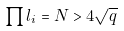Convert formula to latex. <formula><loc_0><loc_0><loc_500><loc_500>\prod l _ { i } = N > 4 \sqrt { q }</formula> 